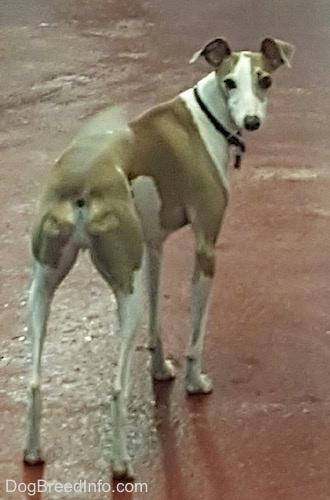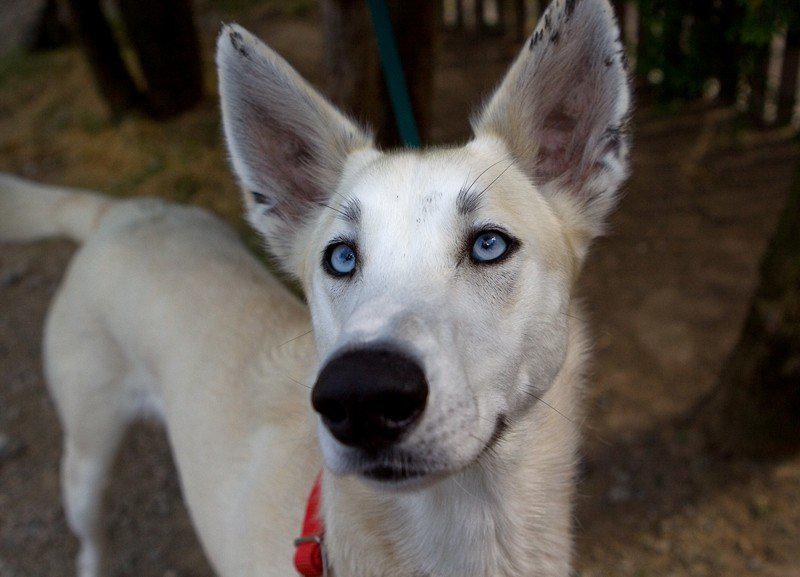The first image is the image on the left, the second image is the image on the right. Considering the images on both sides, is "A dog is standing on all four legs with it's full body visible." valid? Answer yes or no. Yes. The first image is the image on the left, the second image is the image on the right. Analyze the images presented: Is the assertion "Left image shows a hound standing on a hard surface." valid? Answer yes or no. Yes. 